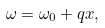<formula> <loc_0><loc_0><loc_500><loc_500>\omega = \omega _ { 0 } + q x ,</formula> 